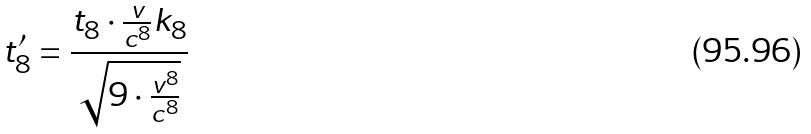Convert formula to latex. <formula><loc_0><loc_0><loc_500><loc_500>t _ { 8 } ^ { \prime } = \frac { t _ { 8 } \cdot \frac { v } { c ^ { 8 } } k _ { 8 } } { \sqrt { 9 \cdot \frac { v ^ { 8 } } { c ^ { 8 } } } }</formula> 